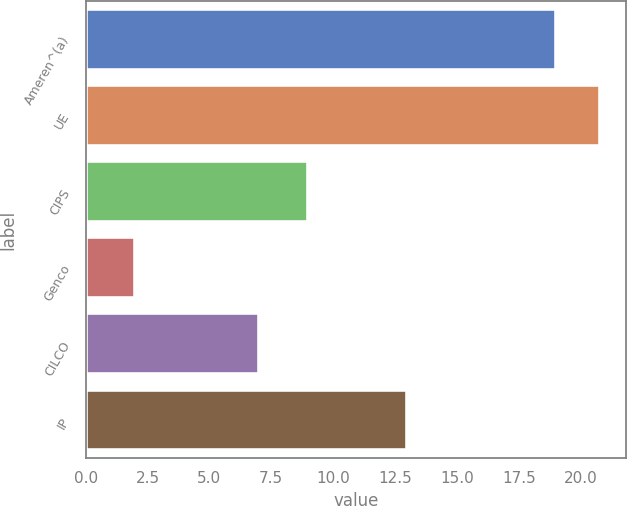Convert chart to OTSL. <chart><loc_0><loc_0><loc_500><loc_500><bar_chart><fcel>Ameren^(a)<fcel>UE<fcel>CIPS<fcel>Genco<fcel>CILCO<fcel>IP<nl><fcel>19<fcel>20.8<fcel>9<fcel>2<fcel>7<fcel>13<nl></chart> 